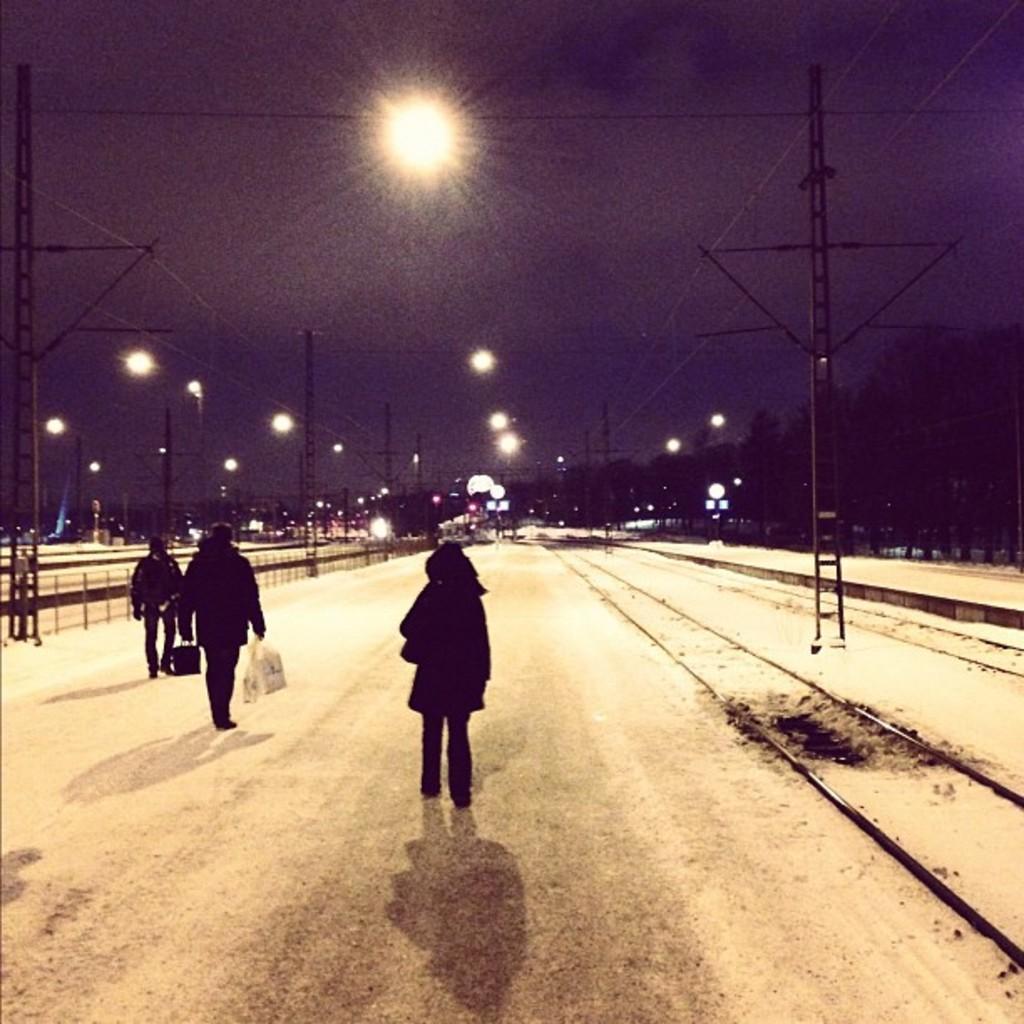Please provide a concise description of this image. In this image we can see people walking on the road and one of them is holding polythene bags in the hands, street poles, street lights, electric poles, electric cables, trees and sky. 